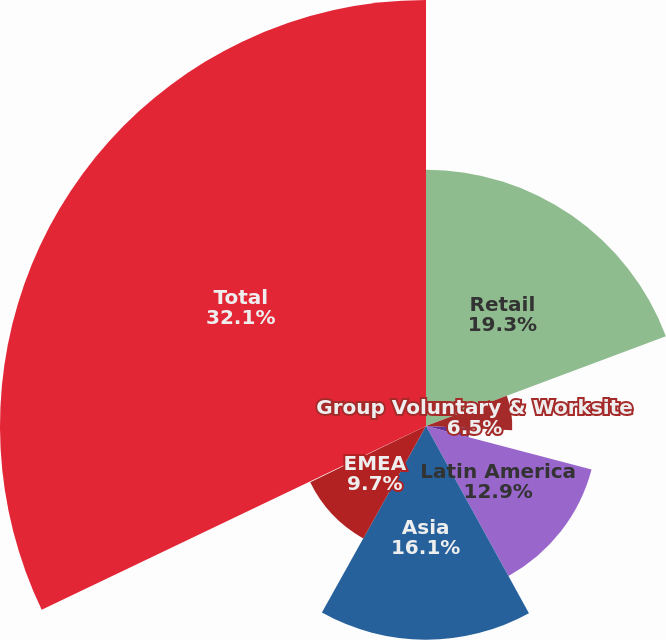Convert chart to OTSL. <chart><loc_0><loc_0><loc_500><loc_500><pie_chart><fcel>Retail<fcel>Group Voluntary & Worksite<fcel>Corporate Benefit Funding<fcel>Latin America<fcel>Asia<fcel>EMEA<fcel>Corporate & Other<fcel>Total<nl><fcel>19.3%<fcel>6.5%<fcel>3.3%<fcel>12.9%<fcel>16.1%<fcel>9.7%<fcel>0.1%<fcel>32.1%<nl></chart> 